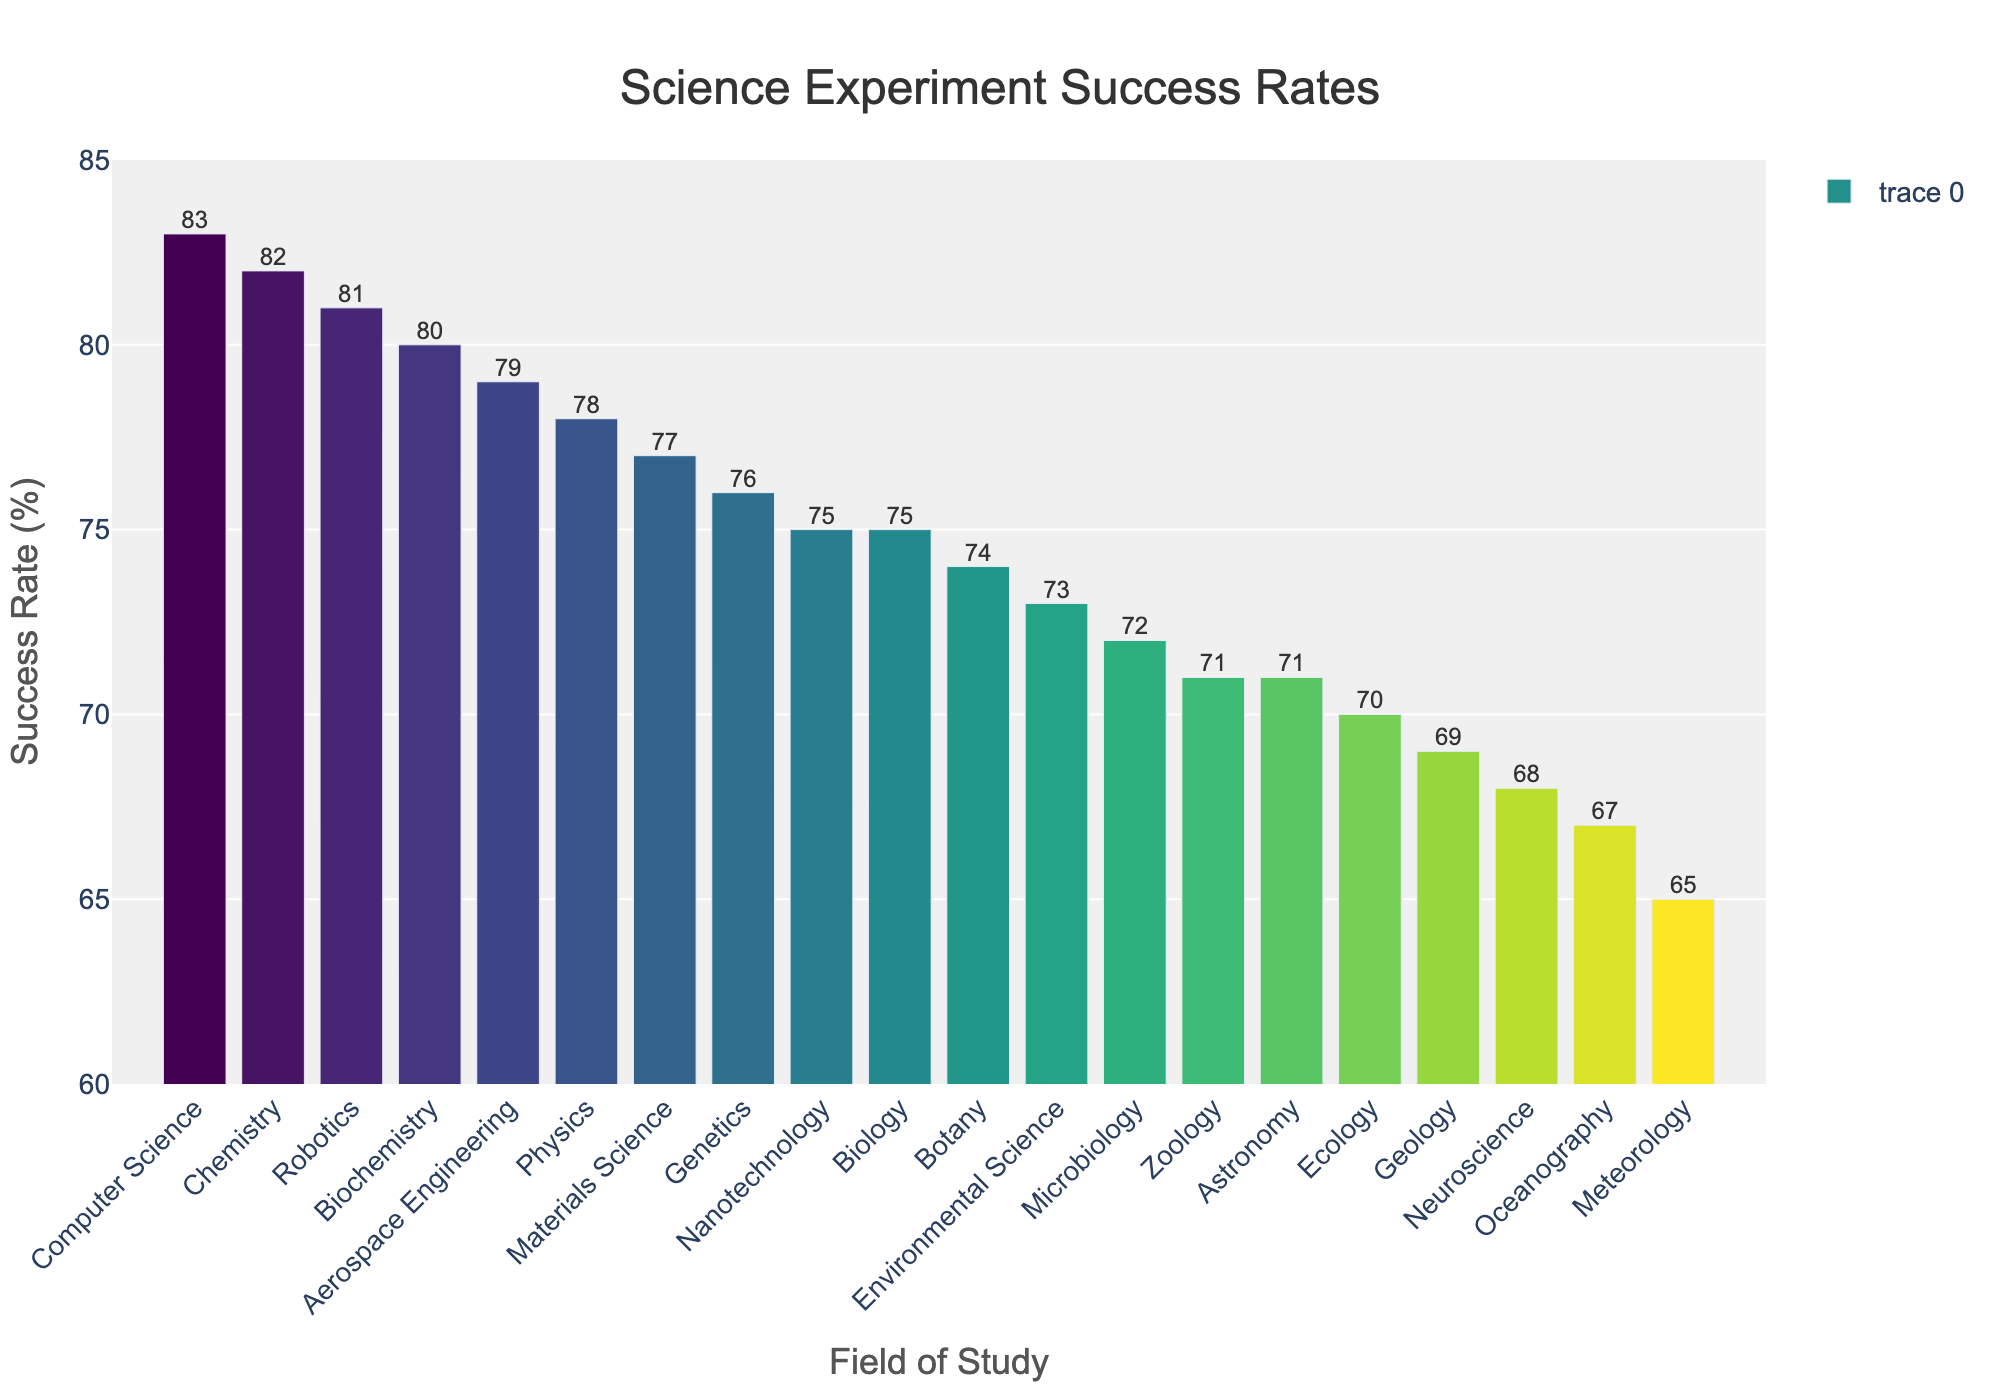What's the field with the highest success rate? Check the bar chart and identify the bar that reaches the highest point. The tallest bar corresponds to Computer Science with a success rate of 83%.
Answer: Computer Science What's the difference between the success rates of Chemistry and Geology? Find the heights of the bars representing Chemistry (82%) and Geology (69%). Subtract the lower value from the higher value: 82% - 69% = 13%.
Answer: 13% Is the success rate of Astronomy higher or lower than that of Botany? Compare the heights of the bars for Astronomy (71%) and Botany (74%). The bar for Botany is higher.
Answer: Lower How many fields have a success rate of 75% or higher? Count all the fields where the bar heights represent a success rate of 75% or more. Fields meeting the criterion: Physics, Chemistry, Biology, Genetics, Biochemistry, Robotics, Computer Science, Materials Science, Aerospace Engineering, and Nanotechnology. This gives 10 fields.
Answer: 10 What's the combined success rate of Neuroscience and Meteorology? Look at the bars for Neuroscience (68%) and Meteorology (65%). Add these values together: 68% + 65% = 133%.
Answer: 133% Which field has a slightly higher success rate: Zoology or Oceanography? Compare the bars for Zoology (71%) and Oceanography (67%). The bar for Zoology is higher.
Answer: Zoology What's the average success rate of Physics, Chemistry, and Biology? Find the heights of the bars for Physics (78%), Chemistry (82%), and Biology (75%). Calculate the average: (78% + 82% + 75%) / 3 = 78.33%.
Answer: 78.33% What's the range of success rates shown in the chart? Identify the highest (Computer Science, 83%) and lowest (Meteorology, 65%) success rates. Subtract the lowest from the highest: 83% - 65% = 18%.
Answer: 18% What is the median success rate of the fields listed? Sort all the success rates in ascending order and find the middle value. Sorted rates: 65%, 67%, 68%, 69%, 70%, 71%, 71%, 72%, 73%, 74%, 75%, 75%, 76%, 77%, 78%, 79%, 80%, 81%, 82%, 83%. With 20 values, the median will be the average of the 10th and 11th values: (74% + 75%) / 2 = 74.5%.
Answer: 74.5% Which two fields have nearly similar success rates but fall below 72%? Compare the bars and find close values below 72%. The fields with 71% are Zoology and Astronomy.
Answer: Zoology and Astronomy 